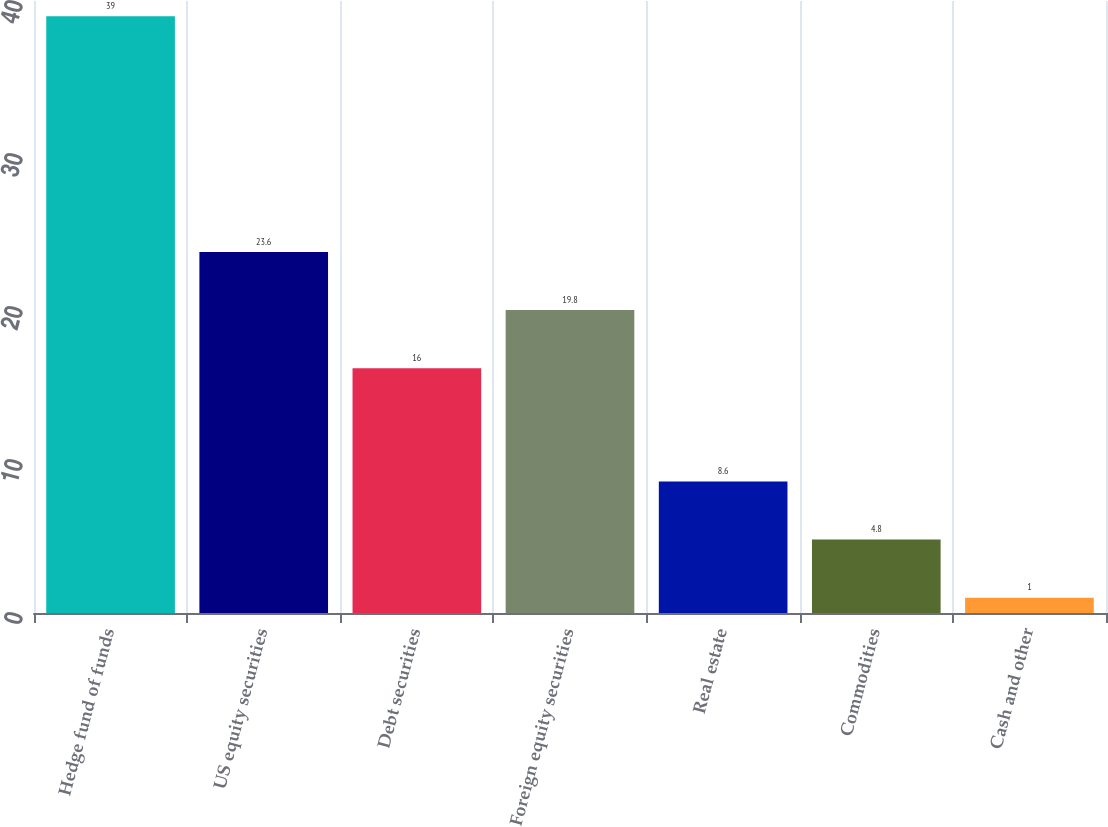Convert chart to OTSL. <chart><loc_0><loc_0><loc_500><loc_500><bar_chart><fcel>Hedge fund of funds<fcel>US equity securities<fcel>Debt securities<fcel>Foreign equity securities<fcel>Real estate<fcel>Commodities<fcel>Cash and other<nl><fcel>39<fcel>23.6<fcel>16<fcel>19.8<fcel>8.6<fcel>4.8<fcel>1<nl></chart> 